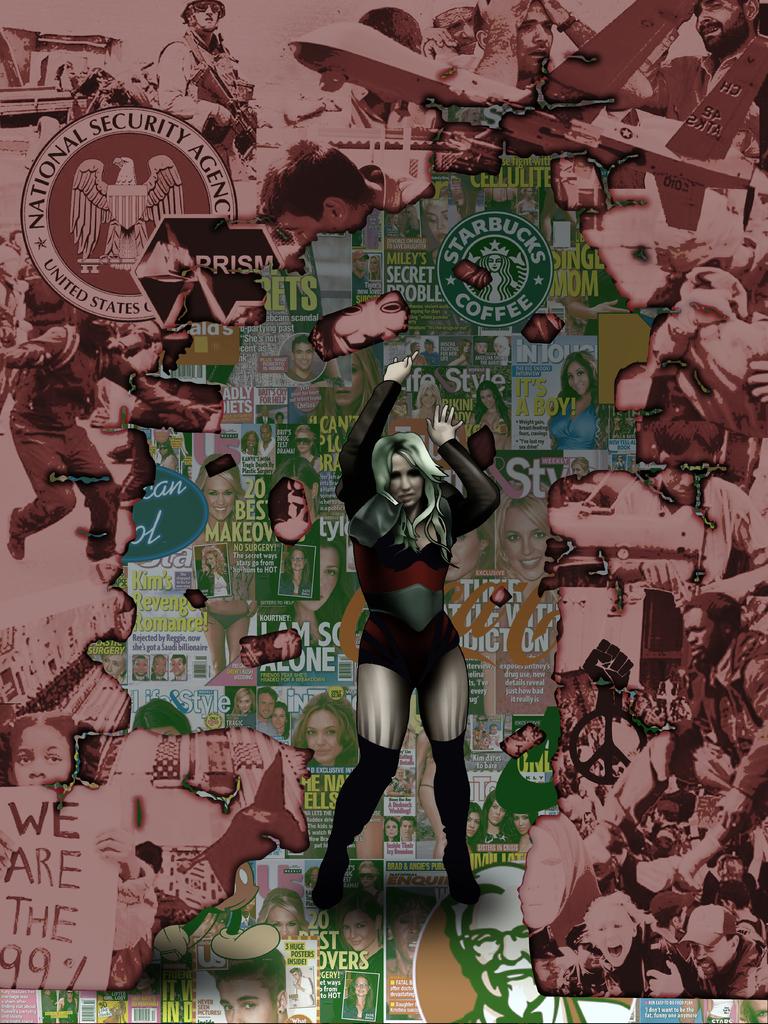What coffee company is shown above the woman?
Your response must be concise. Starbucks. 